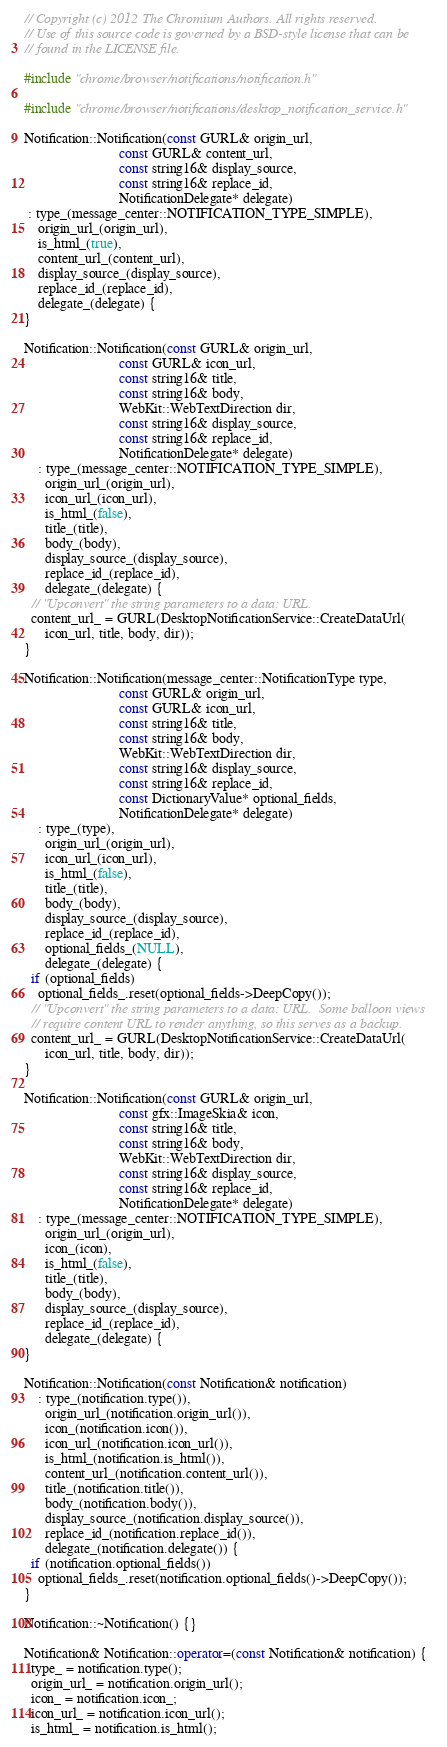<code> <loc_0><loc_0><loc_500><loc_500><_C++_>// Copyright (c) 2012 The Chromium Authors. All rights reserved.
// Use of this source code is governed by a BSD-style license that can be
// found in the LICENSE file.

#include "chrome/browser/notifications/notification.h"

#include "chrome/browser/notifications/desktop_notification_service.h"

Notification::Notification(const GURL& origin_url,
                           const GURL& content_url,
                           const string16& display_source,
                           const string16& replace_id,
                           NotificationDelegate* delegate)
 : type_(message_center::NOTIFICATION_TYPE_SIMPLE),
    origin_url_(origin_url),
    is_html_(true),
    content_url_(content_url),
    display_source_(display_source),
    replace_id_(replace_id),
    delegate_(delegate) {
}

Notification::Notification(const GURL& origin_url,
                           const GURL& icon_url,
                           const string16& title,
                           const string16& body,
                           WebKit::WebTextDirection dir,
                           const string16& display_source,
                           const string16& replace_id,
                           NotificationDelegate* delegate)
    : type_(message_center::NOTIFICATION_TYPE_SIMPLE),
      origin_url_(origin_url),
      icon_url_(icon_url),
      is_html_(false),
      title_(title),
      body_(body),
      display_source_(display_source),
      replace_id_(replace_id),
      delegate_(delegate) {
  // "Upconvert" the string parameters to a data: URL.
  content_url_ = GURL(DesktopNotificationService::CreateDataUrl(
      icon_url, title, body, dir));
}

Notification::Notification(message_center::NotificationType type,
                           const GURL& origin_url,
                           const GURL& icon_url,
                           const string16& title,
                           const string16& body,
                           WebKit::WebTextDirection dir,
                           const string16& display_source,
                           const string16& replace_id,
                           const DictionaryValue* optional_fields,
                           NotificationDelegate* delegate)
    : type_(type),
      origin_url_(origin_url),
      icon_url_(icon_url),
      is_html_(false),
      title_(title),
      body_(body),
      display_source_(display_source),
      replace_id_(replace_id),
      optional_fields_(NULL),
      delegate_(delegate) {
  if (optional_fields)
    optional_fields_.reset(optional_fields->DeepCopy());
  // "Upconvert" the string parameters to a data: URL.  Some balloon views
  // require content URL to render anything, so this serves as a backup.
  content_url_ = GURL(DesktopNotificationService::CreateDataUrl(
      icon_url, title, body, dir));
}

Notification::Notification(const GURL& origin_url,
                           const gfx::ImageSkia& icon,
                           const string16& title,
                           const string16& body,
                           WebKit::WebTextDirection dir,
                           const string16& display_source,
                           const string16& replace_id,
                           NotificationDelegate* delegate)
    : type_(message_center::NOTIFICATION_TYPE_SIMPLE),
      origin_url_(origin_url),
      icon_(icon),
      is_html_(false),
      title_(title),
      body_(body),
      display_source_(display_source),
      replace_id_(replace_id),
      delegate_(delegate) {
}

Notification::Notification(const Notification& notification)
    : type_(notification.type()),
      origin_url_(notification.origin_url()),
      icon_(notification.icon()),
      icon_url_(notification.icon_url()),
      is_html_(notification.is_html()),
      content_url_(notification.content_url()),
      title_(notification.title()),
      body_(notification.body()),
      display_source_(notification.display_source()),
      replace_id_(notification.replace_id()),
      delegate_(notification.delegate()) {
  if (notification.optional_fields())
    optional_fields_.reset(notification.optional_fields()->DeepCopy());
}

Notification::~Notification() {}

Notification& Notification::operator=(const Notification& notification) {
  type_ = notification.type();
  origin_url_ = notification.origin_url();
  icon_ = notification.icon_;
  icon_url_ = notification.icon_url();
  is_html_ = notification.is_html();</code> 